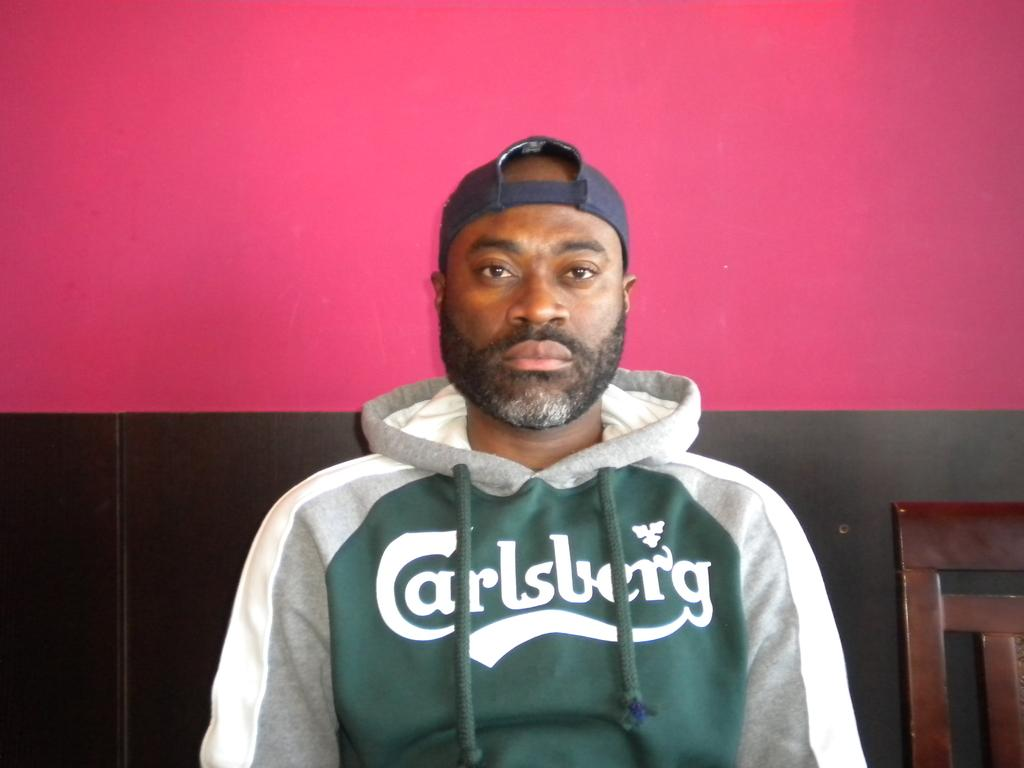<image>
Share a concise interpretation of the image provided. A man with a expressionless face wears a Carlsberg hoodie. 